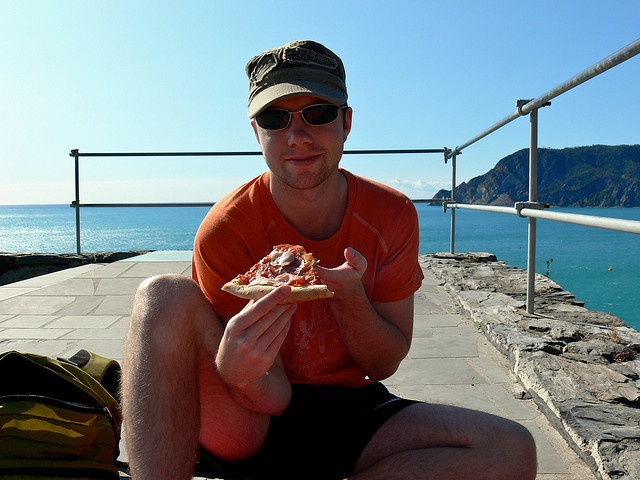Describe the objects in this image and their specific colors. I can see people in lightblue, maroon, black, and gray tones, backpack in lightblue, black, olive, maroon, and lightgray tones, pizza in lightblue, maroon, ivory, brown, and tan tones, and people in lightblue, gray, olive, darkgray, and black tones in this image. 